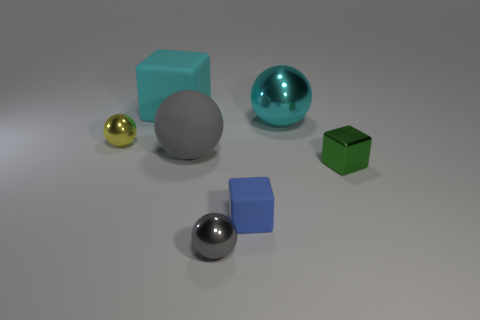Add 3 gray balls. How many objects exist? 10 Subtract all blocks. How many objects are left? 4 Add 6 big cubes. How many big cubes are left? 7 Add 7 blue blocks. How many blue blocks exist? 8 Subtract 2 gray balls. How many objects are left? 5 Subtract all tiny matte cubes. Subtract all tiny yellow spheres. How many objects are left? 5 